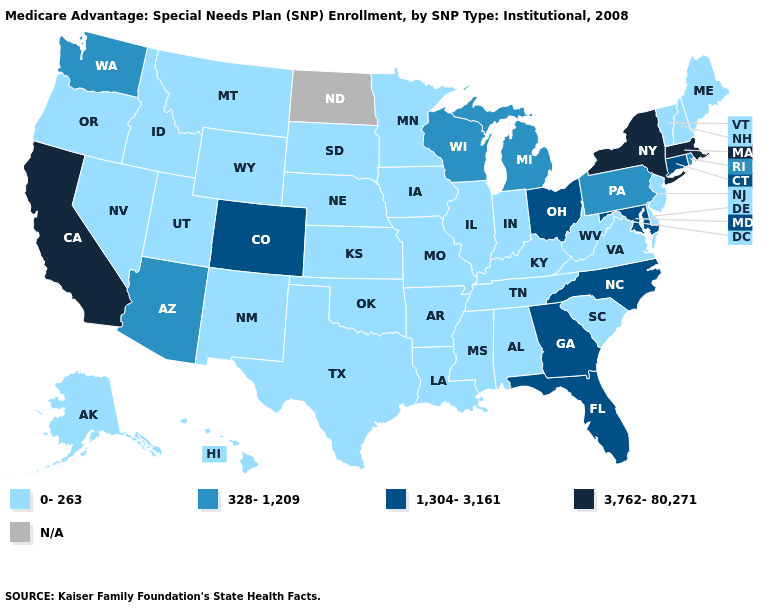Name the states that have a value in the range N/A?
Write a very short answer. North Dakota. Which states have the lowest value in the Northeast?
Give a very brief answer. Maine, New Hampshire, New Jersey, Vermont. What is the value of Connecticut?
Quick response, please. 1,304-3,161. Name the states that have a value in the range 328-1,209?
Answer briefly. Arizona, Michigan, Pennsylvania, Rhode Island, Washington, Wisconsin. Name the states that have a value in the range 328-1,209?
Answer briefly. Arizona, Michigan, Pennsylvania, Rhode Island, Washington, Wisconsin. Which states have the highest value in the USA?
Give a very brief answer. California, Massachusetts, New York. Name the states that have a value in the range 328-1,209?
Keep it brief. Arizona, Michigan, Pennsylvania, Rhode Island, Washington, Wisconsin. Does the map have missing data?
Concise answer only. Yes. What is the lowest value in the USA?
Keep it brief. 0-263. What is the lowest value in the West?
Write a very short answer. 0-263. Name the states that have a value in the range 0-263?
Give a very brief answer. Alaska, Alabama, Arkansas, Delaware, Hawaii, Iowa, Idaho, Illinois, Indiana, Kansas, Kentucky, Louisiana, Maine, Minnesota, Missouri, Mississippi, Montana, Nebraska, New Hampshire, New Jersey, New Mexico, Nevada, Oklahoma, Oregon, South Carolina, South Dakota, Tennessee, Texas, Utah, Virginia, Vermont, West Virginia, Wyoming. What is the highest value in states that border Montana?
Concise answer only. 0-263. Which states have the highest value in the USA?
Be succinct. California, Massachusetts, New York. 